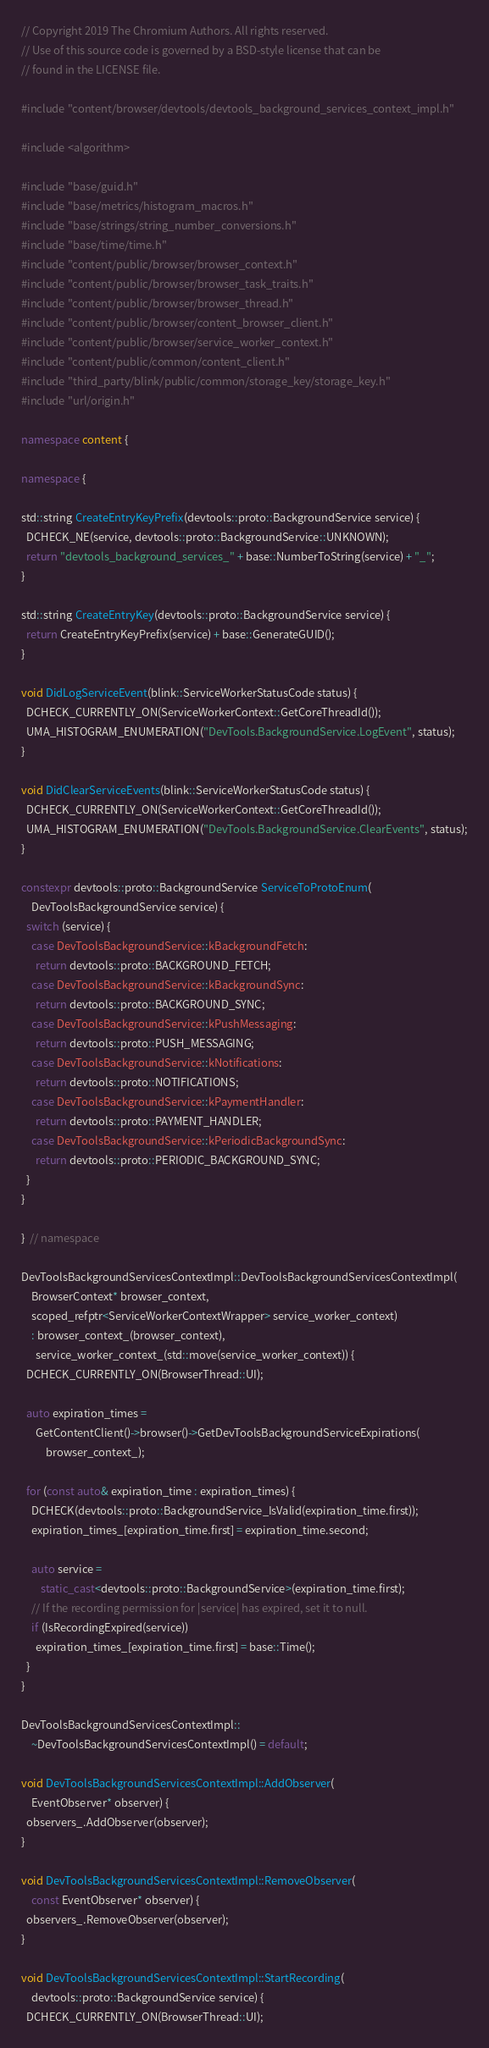Convert code to text. <code><loc_0><loc_0><loc_500><loc_500><_C++_>// Copyright 2019 The Chromium Authors. All rights reserved.
// Use of this source code is governed by a BSD-style license that can be
// found in the LICENSE file.

#include "content/browser/devtools/devtools_background_services_context_impl.h"

#include <algorithm>

#include "base/guid.h"
#include "base/metrics/histogram_macros.h"
#include "base/strings/string_number_conversions.h"
#include "base/time/time.h"
#include "content/public/browser/browser_context.h"
#include "content/public/browser/browser_task_traits.h"
#include "content/public/browser/browser_thread.h"
#include "content/public/browser/content_browser_client.h"
#include "content/public/browser/service_worker_context.h"
#include "content/public/common/content_client.h"
#include "third_party/blink/public/common/storage_key/storage_key.h"
#include "url/origin.h"

namespace content {

namespace {

std::string CreateEntryKeyPrefix(devtools::proto::BackgroundService service) {
  DCHECK_NE(service, devtools::proto::BackgroundService::UNKNOWN);
  return "devtools_background_services_" + base::NumberToString(service) + "_";
}

std::string CreateEntryKey(devtools::proto::BackgroundService service) {
  return CreateEntryKeyPrefix(service) + base::GenerateGUID();
}

void DidLogServiceEvent(blink::ServiceWorkerStatusCode status) {
  DCHECK_CURRENTLY_ON(ServiceWorkerContext::GetCoreThreadId());
  UMA_HISTOGRAM_ENUMERATION("DevTools.BackgroundService.LogEvent", status);
}

void DidClearServiceEvents(blink::ServiceWorkerStatusCode status) {
  DCHECK_CURRENTLY_ON(ServiceWorkerContext::GetCoreThreadId());
  UMA_HISTOGRAM_ENUMERATION("DevTools.BackgroundService.ClearEvents", status);
}

constexpr devtools::proto::BackgroundService ServiceToProtoEnum(
    DevToolsBackgroundService service) {
  switch (service) {
    case DevToolsBackgroundService::kBackgroundFetch:
      return devtools::proto::BACKGROUND_FETCH;
    case DevToolsBackgroundService::kBackgroundSync:
      return devtools::proto::BACKGROUND_SYNC;
    case DevToolsBackgroundService::kPushMessaging:
      return devtools::proto::PUSH_MESSAGING;
    case DevToolsBackgroundService::kNotifications:
      return devtools::proto::NOTIFICATIONS;
    case DevToolsBackgroundService::kPaymentHandler:
      return devtools::proto::PAYMENT_HANDLER;
    case DevToolsBackgroundService::kPeriodicBackgroundSync:
      return devtools::proto::PERIODIC_BACKGROUND_SYNC;
  }
}

}  // namespace

DevToolsBackgroundServicesContextImpl::DevToolsBackgroundServicesContextImpl(
    BrowserContext* browser_context,
    scoped_refptr<ServiceWorkerContextWrapper> service_worker_context)
    : browser_context_(browser_context),
      service_worker_context_(std::move(service_worker_context)) {
  DCHECK_CURRENTLY_ON(BrowserThread::UI);

  auto expiration_times =
      GetContentClient()->browser()->GetDevToolsBackgroundServiceExpirations(
          browser_context_);

  for (const auto& expiration_time : expiration_times) {
    DCHECK(devtools::proto::BackgroundService_IsValid(expiration_time.first));
    expiration_times_[expiration_time.first] = expiration_time.second;

    auto service =
        static_cast<devtools::proto::BackgroundService>(expiration_time.first);
    // If the recording permission for |service| has expired, set it to null.
    if (IsRecordingExpired(service))
      expiration_times_[expiration_time.first] = base::Time();
  }
}

DevToolsBackgroundServicesContextImpl::
    ~DevToolsBackgroundServicesContextImpl() = default;

void DevToolsBackgroundServicesContextImpl::AddObserver(
    EventObserver* observer) {
  observers_.AddObserver(observer);
}

void DevToolsBackgroundServicesContextImpl::RemoveObserver(
    const EventObserver* observer) {
  observers_.RemoveObserver(observer);
}

void DevToolsBackgroundServicesContextImpl::StartRecording(
    devtools::proto::BackgroundService service) {
  DCHECK_CURRENTLY_ON(BrowserThread::UI);
</code> 